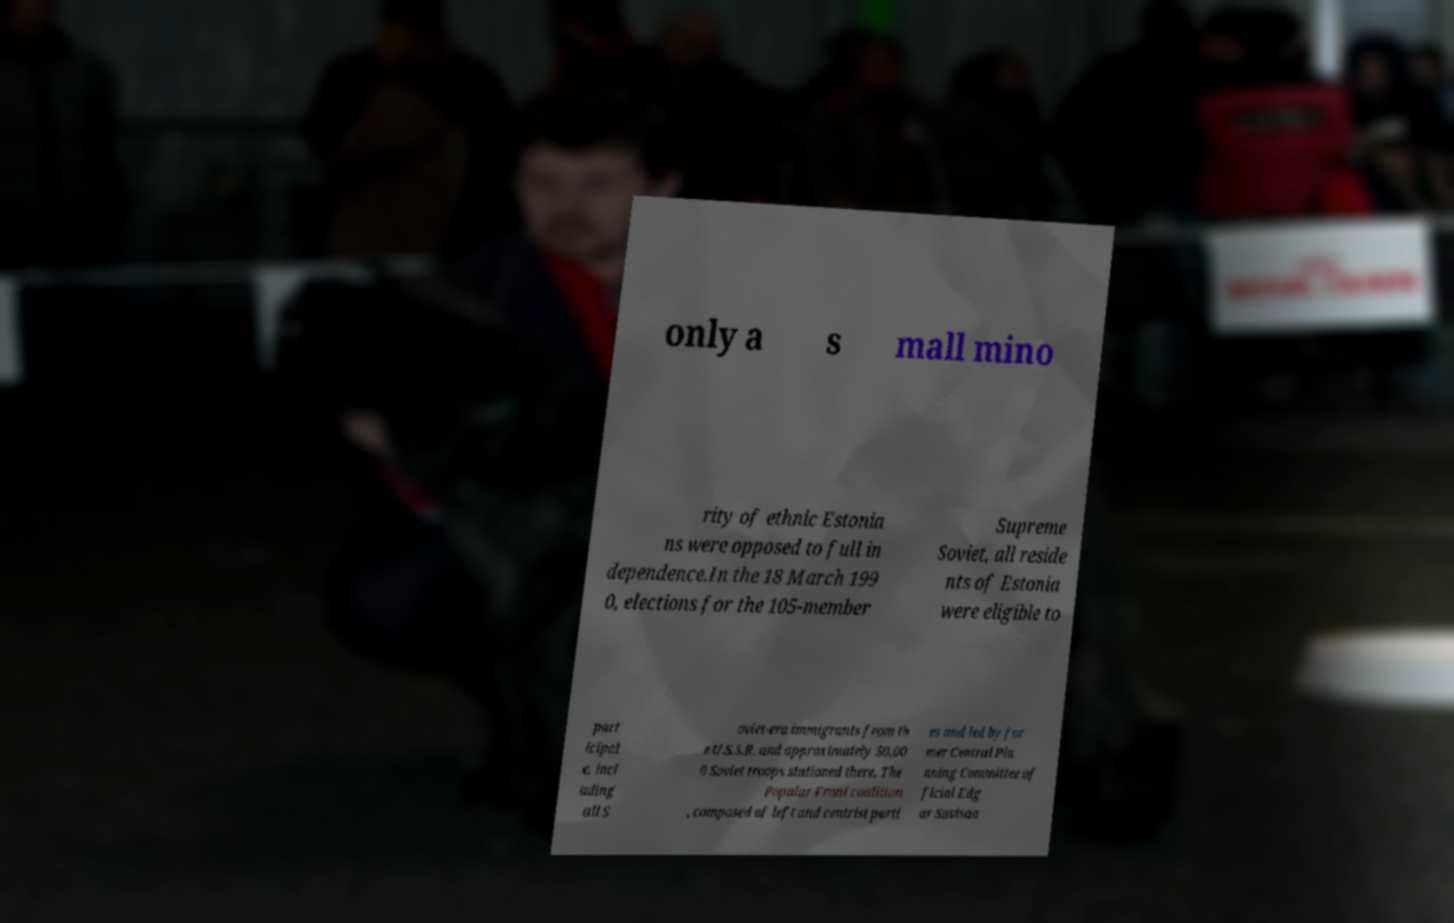I need the written content from this picture converted into text. Can you do that? only a s mall mino rity of ethnic Estonia ns were opposed to full in dependence.In the 18 March 199 0, elections for the 105-member Supreme Soviet, all reside nts of Estonia were eligible to part icipat e, incl uding all S oviet-era immigrants from th e U.S.S.R. and approximately 50,00 0 Soviet troops stationed there. The Popular Front coalition , composed of left and centrist parti es and led by for mer Central Pla nning Committee of ficial Edg ar Savisaa 